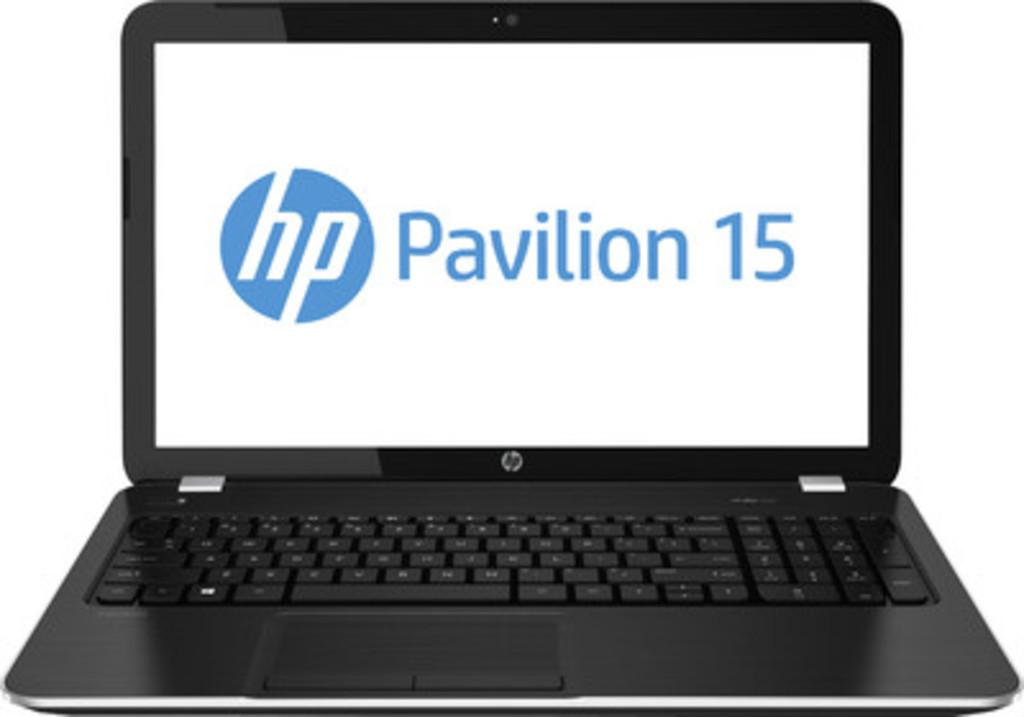What electronic device is visible in the image? There is a laptop in the image. What color is the background of the image? The background of the image is white. How many frogs are participating in the competition in the image? There are no frogs or competition present in the image; it features a laptop with a white background. 